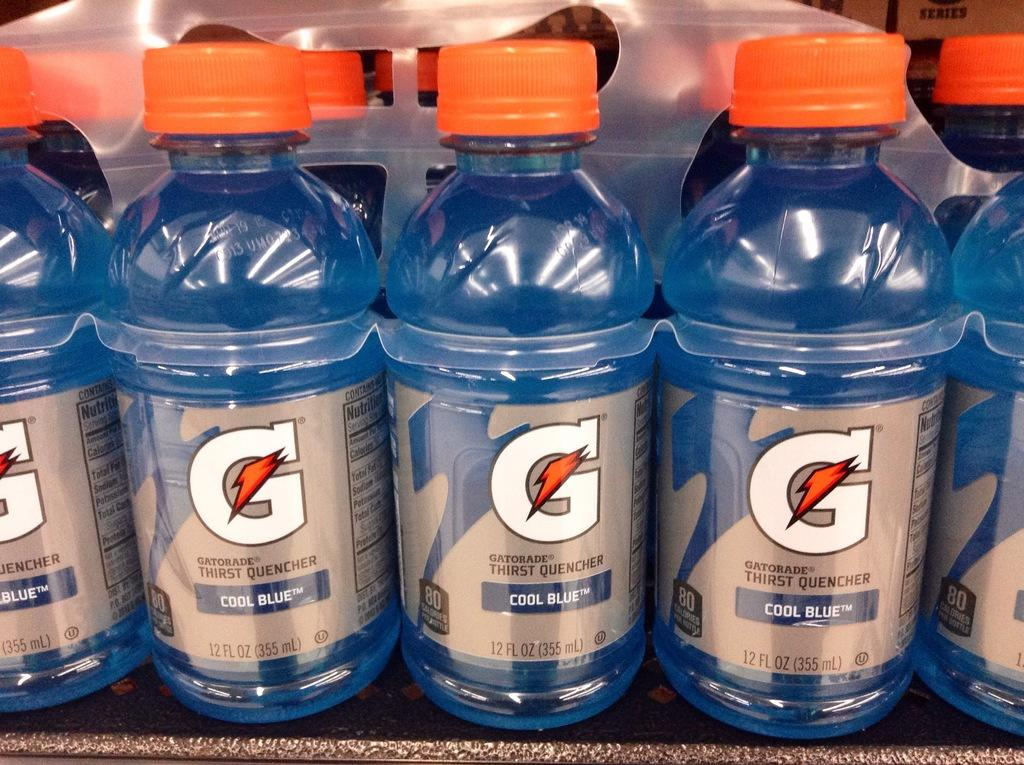Provide a one-sentence caption for the provided image. The bottles contain Gatorade Cool Blue flavor drink. 